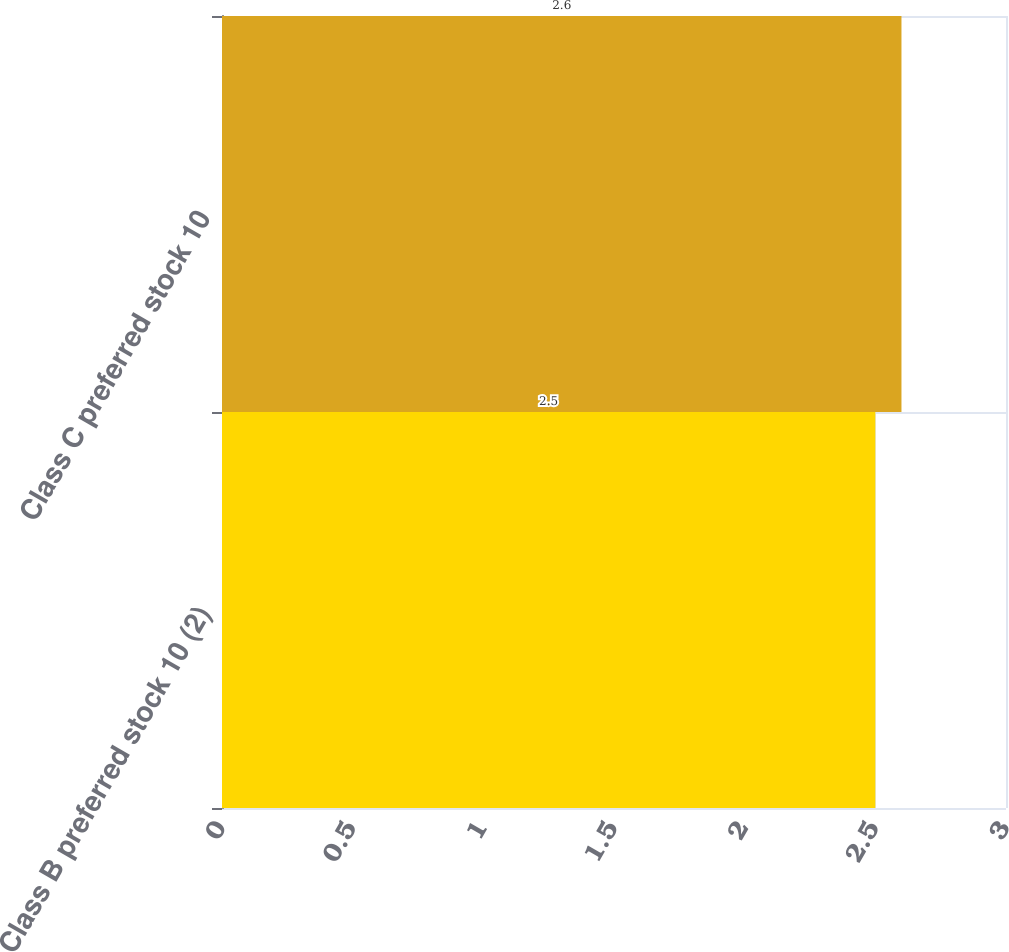<chart> <loc_0><loc_0><loc_500><loc_500><bar_chart><fcel>Class B preferred stock 10 (2)<fcel>Class C preferred stock 10<nl><fcel>2.5<fcel>2.6<nl></chart> 